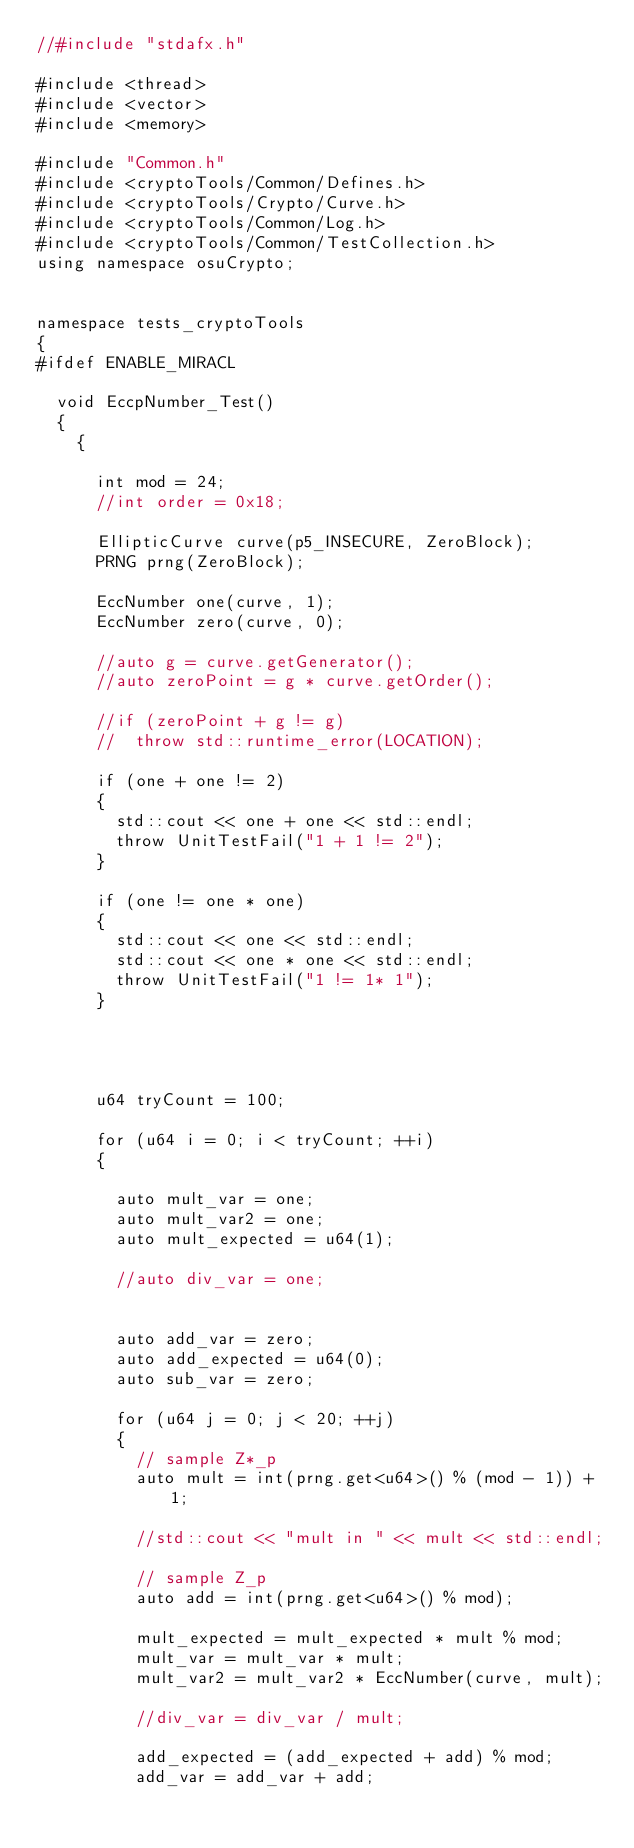Convert code to text. <code><loc_0><loc_0><loc_500><loc_500><_C++_>//#include "stdafx.h"

#include <thread>
#include <vector>
#include <memory>

#include "Common.h"
#include <cryptoTools/Common/Defines.h>
#include <cryptoTools/Crypto/Curve.h>
#include <cryptoTools/Common/Log.h>
#include <cryptoTools/Common/TestCollection.h>
using namespace osuCrypto;


namespace tests_cryptoTools
{
#ifdef ENABLE_MIRACL

	void EccpNumber_Test()
	{
		{

			int mod = 24;
			//int order = 0x18;

			EllipticCurve curve(p5_INSECURE, ZeroBlock);
			PRNG prng(ZeroBlock);

			EccNumber one(curve, 1);
			EccNumber zero(curve, 0);

			//auto g = curve.getGenerator();
			//auto zeroPoint = g * curve.getOrder();

			//if (zeroPoint + g != g)
			//	throw std::runtime_error(LOCATION);

			if (one + one != 2)
			{
				std::cout << one + one << std::endl;
				throw UnitTestFail("1 + 1 != 2");
			}

			if (one != one * one)
			{
				std::cout << one << std::endl;
				std::cout << one * one << std::endl;
				throw UnitTestFail("1 != 1* 1");
			}




			u64 tryCount = 100;

			for (u64 i = 0; i < tryCount; ++i)
			{

				auto mult_var = one;
				auto mult_var2 = one;
				auto mult_expected = u64(1);

				//auto div_var = one;


				auto add_var = zero;
				auto add_expected = u64(0);
				auto sub_var = zero;

				for (u64 j = 0; j < 20; ++j)
				{
					// sample Z*_p
					auto mult = int(prng.get<u64>() % (mod - 1)) + 1;

					//std::cout << "mult in " << mult << std::endl;

					// sample Z_p
					auto add = int(prng.get<u64>() % mod);

					mult_expected = mult_expected * mult % mod;
					mult_var = mult_var * mult;
					mult_var2 = mult_var2 * EccNumber(curve, mult);

					//div_var = div_var / mult;

					add_expected = (add_expected + add) % mod;
					add_var = add_var + add;
</code> 